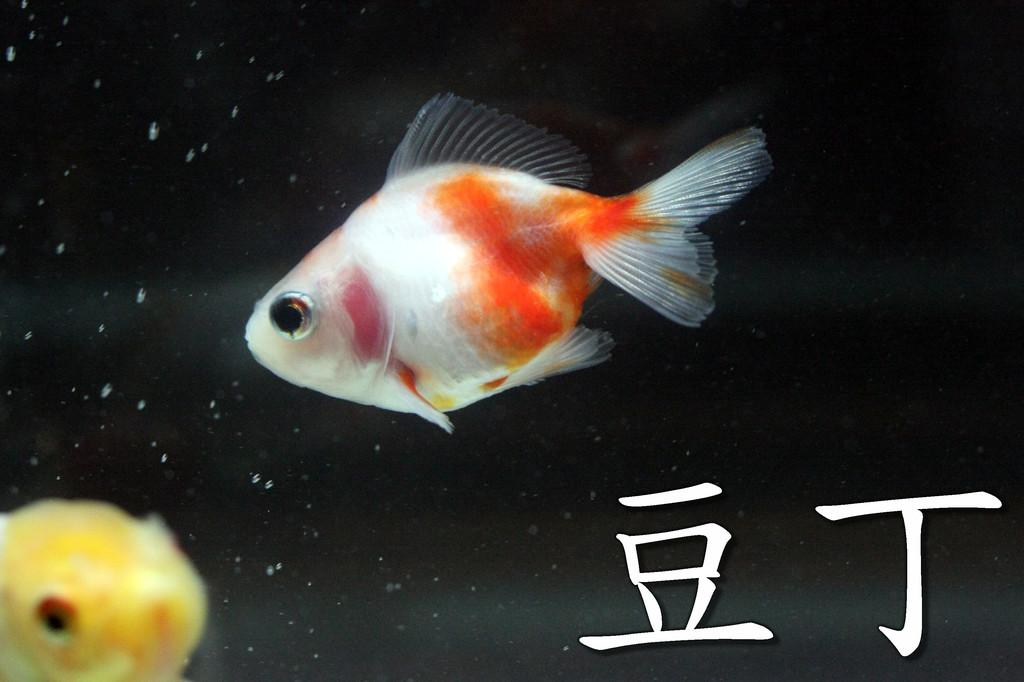What colors are the fish in the image? There is a fish in white and orange color, and another fish in yellow color in the image. Where are the fish located in the image? Both fish are located in the left corner of the image. What can be found in the right corner of the image? There is text or writing in the right corner of the image. Can you hear the fish talking to each other in the image? There is no indication of sound or conversation in the image, so it cannot be determined if the fish are talking to each other. 